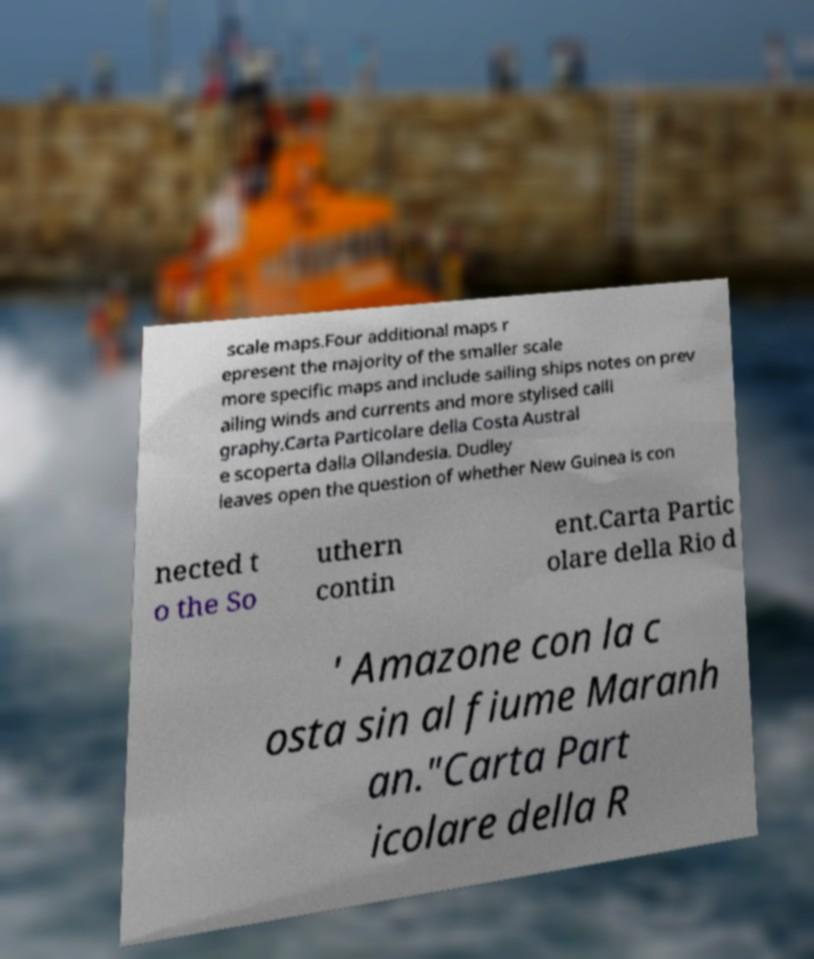I need the written content from this picture converted into text. Can you do that? scale maps.Four additional maps r epresent the majority of the smaller scale more specific maps and include sailing ships notes on prev ailing winds and currents and more stylised calli graphy.Carta Particolare della Costa Austral e scoperta dalla Ollandesia. Dudley leaves open the question of whether New Guinea is con nected t o the So uthern contin ent.Carta Partic olare della Rio d ' Amazone con la c osta sin al fiume Maranh an."Carta Part icolare della R 